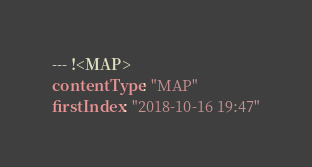<code> <loc_0><loc_0><loc_500><loc_500><_YAML_>--- !<MAP>
contentType: "MAP"
firstIndex: "2018-10-16 19:47"</code> 